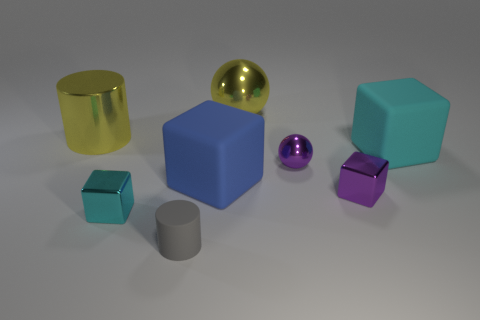What number of other objects are the same material as the blue thing?
Make the answer very short. 2. Is there a small yellow block?
Provide a succinct answer. No. Is the object behind the yellow metallic cylinder made of the same material as the gray cylinder?
Provide a succinct answer. No. What material is the yellow thing that is the same shape as the tiny gray matte object?
Keep it short and to the point. Metal. Are there fewer cyan metallic objects than large metallic objects?
Ensure brevity in your answer.  Yes. There is a small metallic block that is right of the yellow shiny sphere; is it the same color as the small sphere?
Provide a succinct answer. Yes. The big object that is made of the same material as the large yellow cylinder is what color?
Provide a succinct answer. Yellow. Do the purple block and the blue rubber cube have the same size?
Your answer should be very brief. No. What is the yellow sphere made of?
Provide a succinct answer. Metal. What is the material of the gray cylinder that is the same size as the cyan metal object?
Keep it short and to the point. Rubber. 